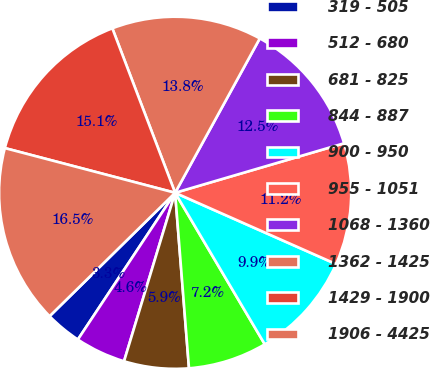<chart> <loc_0><loc_0><loc_500><loc_500><pie_chart><fcel>319 - 505<fcel>512 - 680<fcel>681 - 825<fcel>844 - 887<fcel>900 - 950<fcel>955 - 1051<fcel>1068 - 1360<fcel>1362 - 1425<fcel>1429 - 1900<fcel>1906 - 4425<nl><fcel>3.32%<fcel>4.63%<fcel>5.94%<fcel>7.25%<fcel>9.86%<fcel>11.17%<fcel>12.48%<fcel>13.79%<fcel>15.11%<fcel>16.45%<nl></chart> 